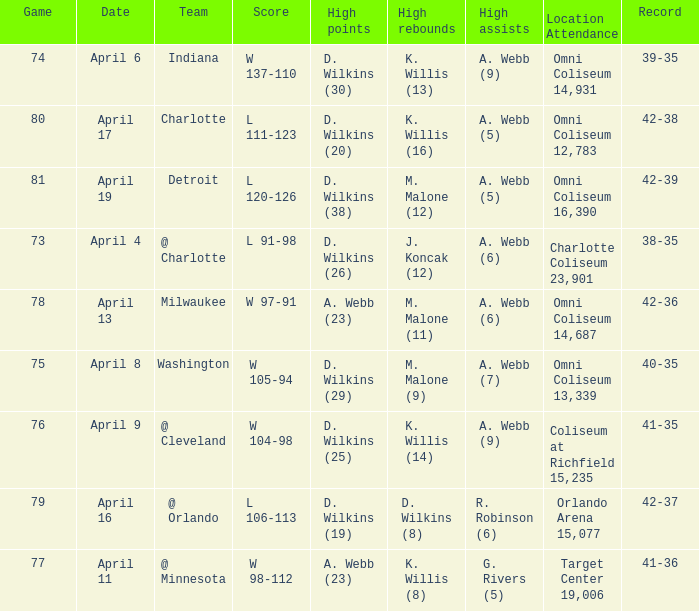What date was the game score w 104-98? April 9. 